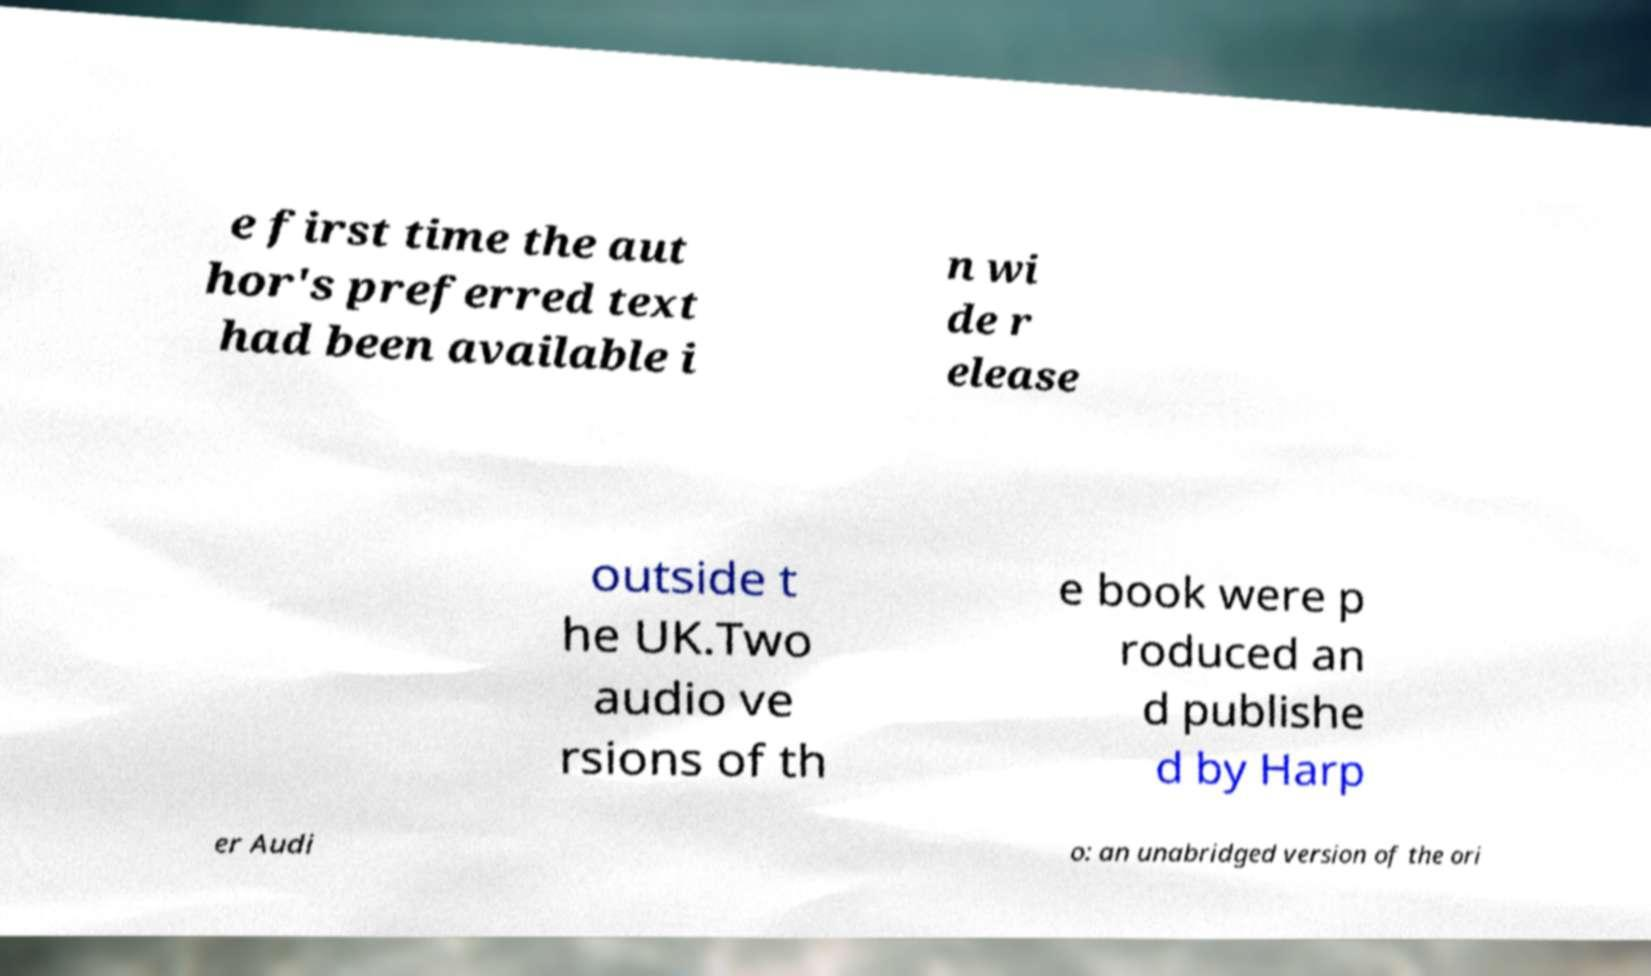I need the written content from this picture converted into text. Can you do that? e first time the aut hor's preferred text had been available i n wi de r elease outside t he UK.Two audio ve rsions of th e book were p roduced an d publishe d by Harp er Audi o: an unabridged version of the ori 